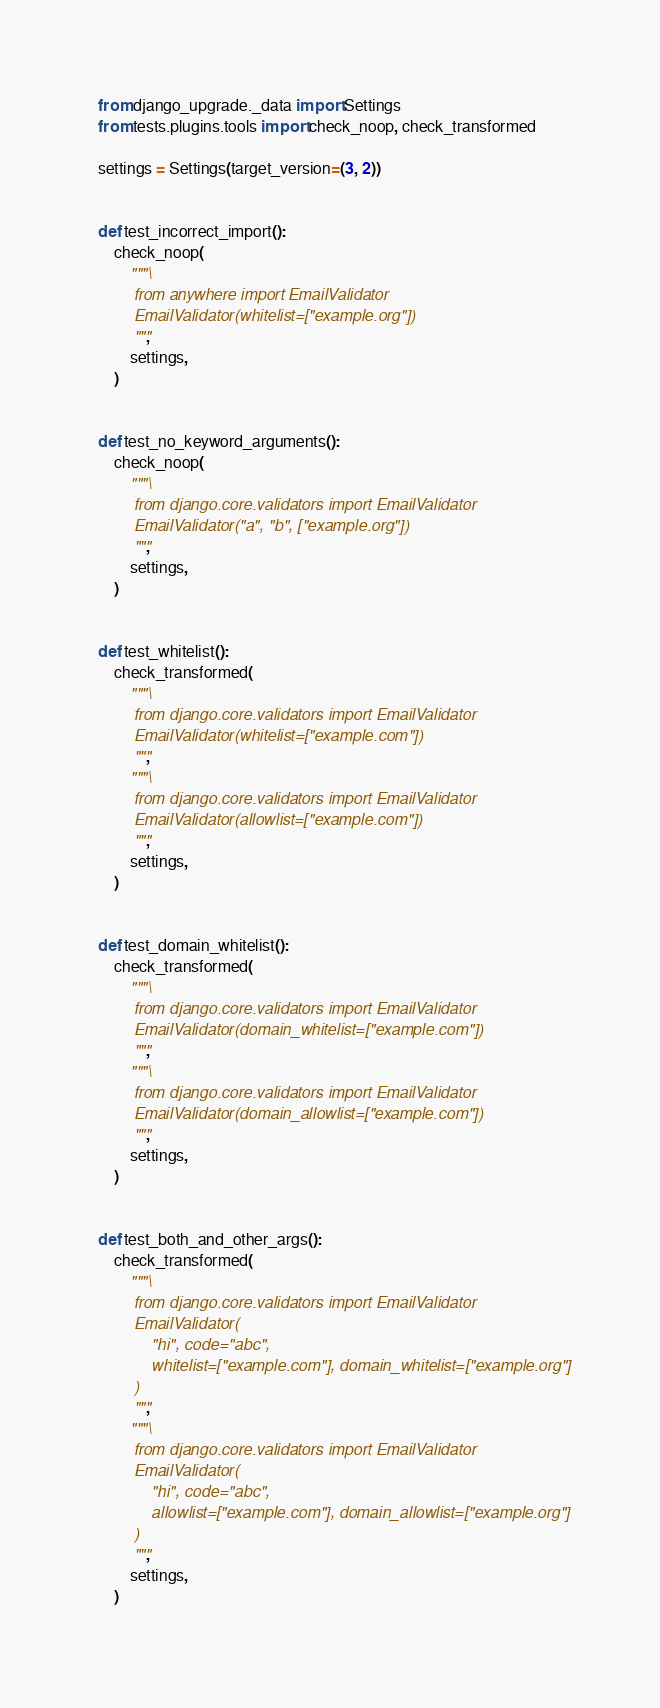Convert code to text. <code><loc_0><loc_0><loc_500><loc_500><_Python_>from django_upgrade._data import Settings
from tests.plugins.tools import check_noop, check_transformed

settings = Settings(target_version=(3, 2))


def test_incorrect_import():
    check_noop(
        """\
        from anywhere import EmailValidator
        EmailValidator(whitelist=["example.org"])
        """,
        settings,
    )


def test_no_keyword_arguments():
    check_noop(
        """\
        from django.core.validators import EmailValidator
        EmailValidator("a", "b", ["example.org"])
        """,
        settings,
    )


def test_whitelist():
    check_transformed(
        """\
        from django.core.validators import EmailValidator
        EmailValidator(whitelist=["example.com"])
        """,
        """\
        from django.core.validators import EmailValidator
        EmailValidator(allowlist=["example.com"])
        """,
        settings,
    )


def test_domain_whitelist():
    check_transformed(
        """\
        from django.core.validators import EmailValidator
        EmailValidator(domain_whitelist=["example.com"])
        """,
        """\
        from django.core.validators import EmailValidator
        EmailValidator(domain_allowlist=["example.com"])
        """,
        settings,
    )


def test_both_and_other_args():
    check_transformed(
        """\
        from django.core.validators import EmailValidator
        EmailValidator(
            "hi", code="abc",
            whitelist=["example.com"], domain_whitelist=["example.org"]
        )
        """,
        """\
        from django.core.validators import EmailValidator
        EmailValidator(
            "hi", code="abc",
            allowlist=["example.com"], domain_allowlist=["example.org"]
        )
        """,
        settings,
    )
</code> 